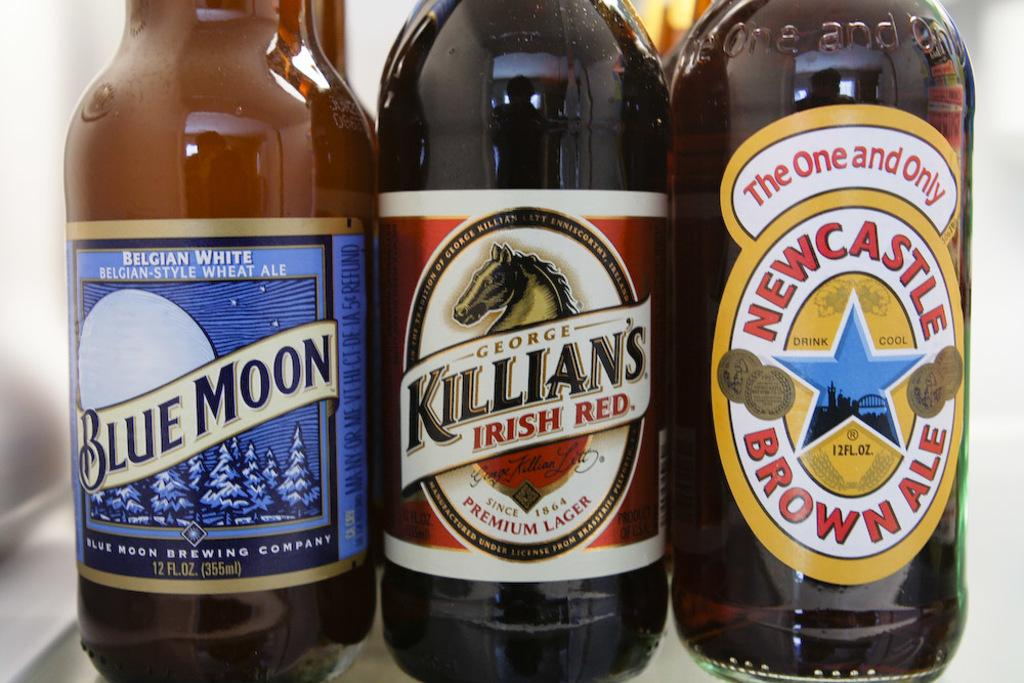What type of beverage containers are present in the image? There are wine bottles in the image. What is the condition of the brick arch in the image? There is no brick arch present in the image; it only features wine bottles. 